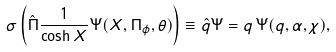<formula> <loc_0><loc_0><loc_500><loc_500>\sigma \left ( \hat { \Pi } \frac { 1 } { \cosh { X } } \Psi ( X , \Pi _ { \phi } , \theta ) \right ) \equiv \hat { q } \Psi = q \, \Psi ( q , \alpha , \chi ) ,</formula> 